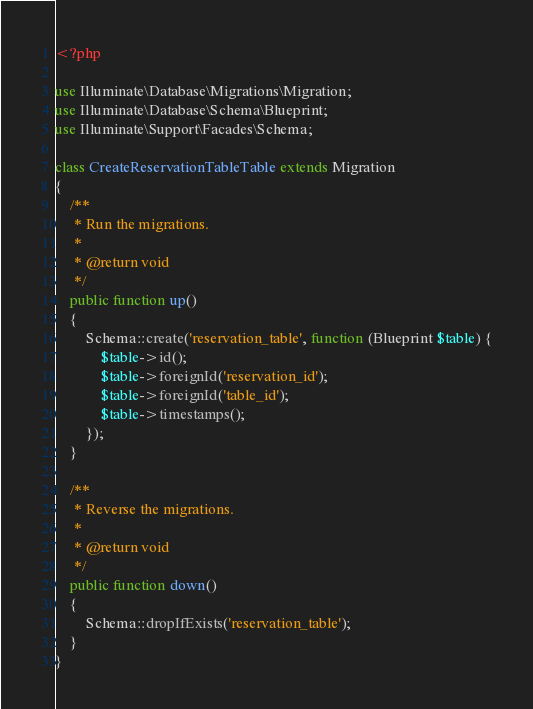<code> <loc_0><loc_0><loc_500><loc_500><_PHP_><?php

use Illuminate\Database\Migrations\Migration;
use Illuminate\Database\Schema\Blueprint;
use Illuminate\Support\Facades\Schema;

class CreateReservationTableTable extends Migration
{
    /**
     * Run the migrations.
     *
     * @return void
     */
    public function up()
    {
        Schema::create('reservation_table', function (Blueprint $table) {
            $table->id();
            $table->foreignId('reservation_id');
            $table->foreignId('table_id');
            $table->timestamps();
        });
    }

    /**
     * Reverse the migrations.
     *
     * @return void
     */
    public function down()
    {
        Schema::dropIfExists('reservation_table');
    }
}
</code> 